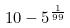<formula> <loc_0><loc_0><loc_500><loc_500>1 0 - 5 ^ { \frac { 1 } { 9 9 } }</formula> 